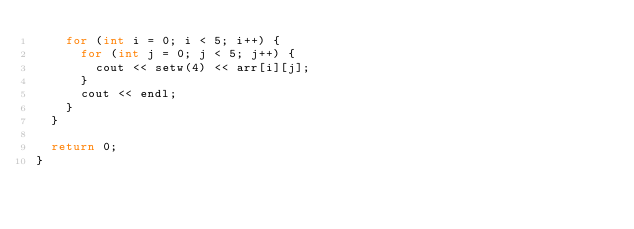<code> <loc_0><loc_0><loc_500><loc_500><_C++_>		for (int i = 0; i < 5; i++) {
			for (int j = 0; j < 5; j++) {
				cout << setw(4) << arr[i][j];
			}
			cout << endl;
		}
	}

	return 0;
}</code> 